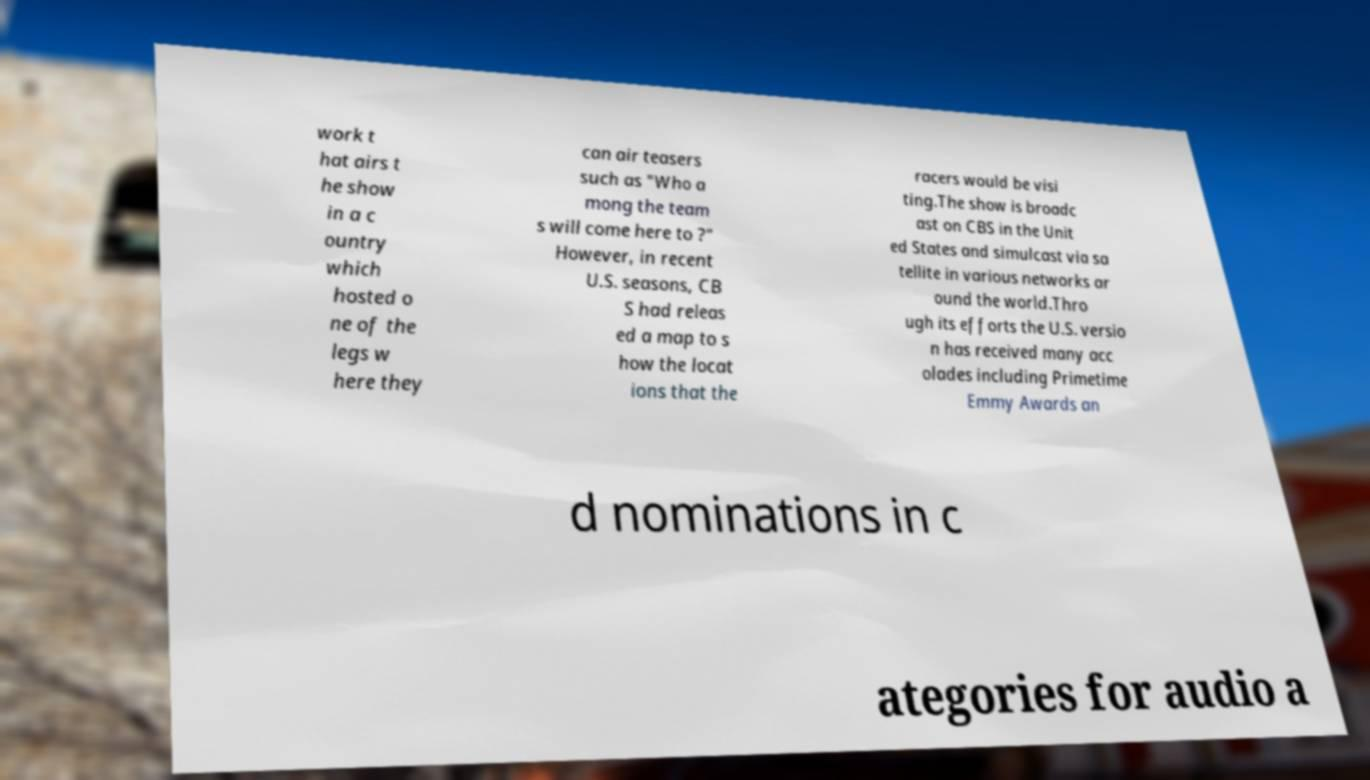Can you read and provide the text displayed in the image?This photo seems to have some interesting text. Can you extract and type it out for me? work t hat airs t he show in a c ountry which hosted o ne of the legs w here they can air teasers such as "Who a mong the team s will come here to ?" However, in recent U.S. seasons, CB S had releas ed a map to s how the locat ions that the racers would be visi ting.The show is broadc ast on CBS in the Unit ed States and simulcast via sa tellite in various networks ar ound the world.Thro ugh its efforts the U.S. versio n has received many acc olades including Primetime Emmy Awards an d nominations in c ategories for audio a 